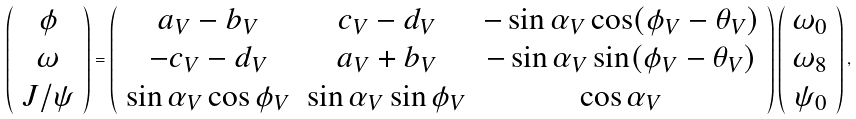<formula> <loc_0><loc_0><loc_500><loc_500>\left ( \begin{array} { c } { \phi } \\ { \omega } \\ { J / \psi } \end{array} \right ) = \left ( \begin{array} { c c c } { { a _ { V } - b _ { V } } } & { { c _ { V } - d _ { V } } } & { { - \sin \alpha _ { V } \cos ( \phi _ { V } - \theta _ { V } ) } } \\ { { - c _ { V } - d _ { V } } } & { { a _ { V } + b _ { V } } } & { { - \sin \alpha _ { V } \sin ( \phi _ { V } - \theta _ { V } ) } } \\ { { \sin \alpha _ { V } \cos \phi _ { V } } } & { { \sin \alpha _ { V } \sin \phi _ { V } } } & { { \cos \alpha _ { V } } } \end{array} \right ) \left ( \begin{array} { c } { { \omega _ { 0 } } } \\ { { \omega _ { 8 } } } \\ { { \psi _ { 0 } } } \end{array} \right ) ,</formula> 